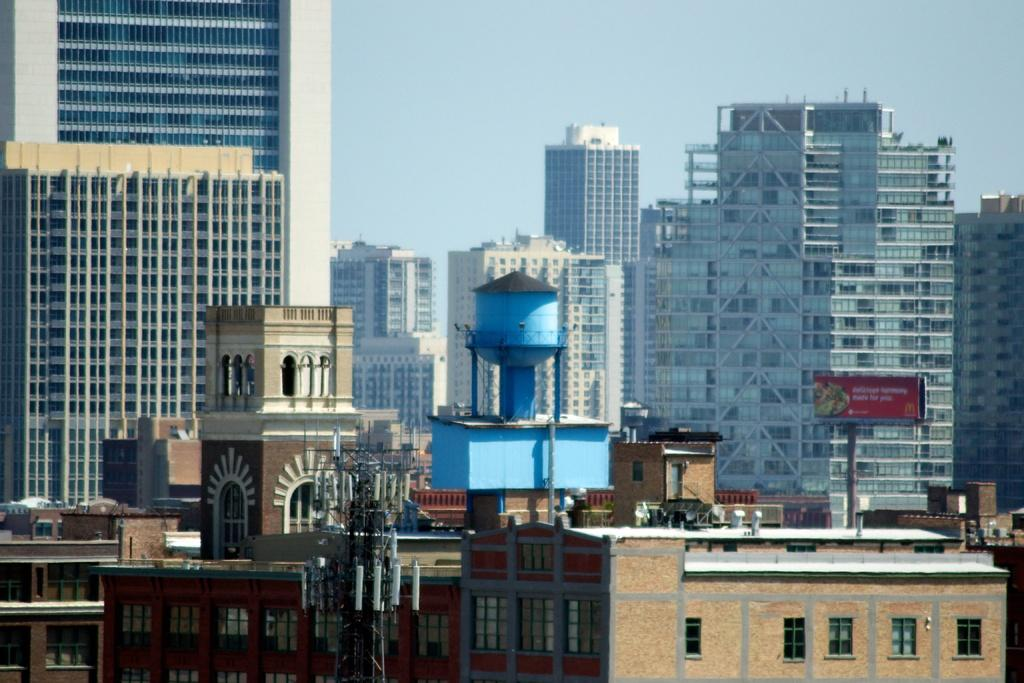What is the main structure in the image? There is a tower in the image. What else can be seen in the image besides the tower? There are many buildings in the image. What part of the natural environment is visible in the image? The sky is visible in the image. Can you describe the board in the image? Yes, the board in the image is in red color. How many lawyers are present in the image? There is no mention of lawyers in the image, so we cannot determine their presence or amount. 